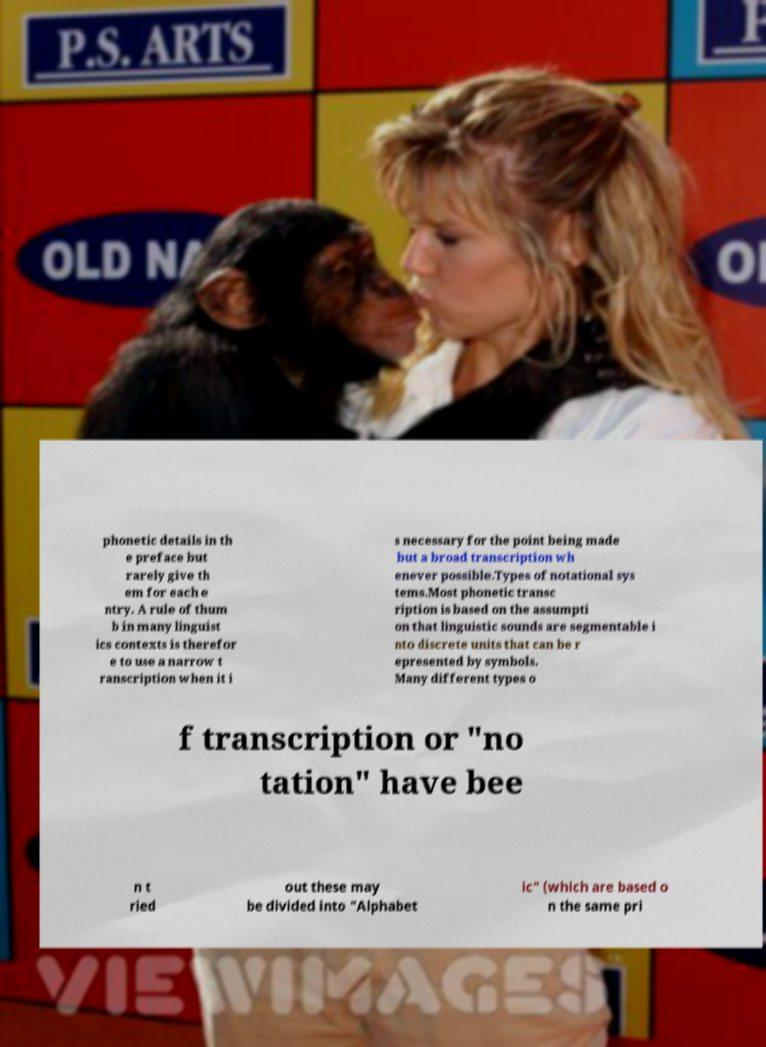I need the written content from this picture converted into text. Can you do that? phonetic details in th e preface but rarely give th em for each e ntry. A rule of thum b in many linguist ics contexts is therefor e to use a narrow t ranscription when it i s necessary for the point being made but a broad transcription wh enever possible.Types of notational sys tems.Most phonetic transc ription is based on the assumpti on that linguistic sounds are segmentable i nto discrete units that can be r epresented by symbols. Many different types o f transcription or "no tation" have bee n t ried out these may be divided into "Alphabet ic" (which are based o n the same pri 